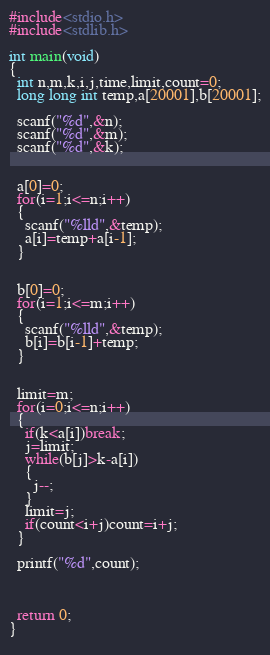<code> <loc_0><loc_0><loc_500><loc_500><_C_>#include<stdio.h>
#include<stdlib.h>

int main(void)
{
  int n,m,k,i,j,time,limit,count=0;
  long long int temp,a[20001],b[20001];
  
  scanf("%d",&n);
  scanf("%d",&m);
  scanf("%d",&k);
  
  
  a[0]=0;
  for(i=1;i<=n;i++)
  {
    scanf("%lld",&temp);
    a[i]=temp+a[i-1];
  }
  

  b[0]=0;
  for(i=1;i<=m;i++)
  {
    scanf("%lld",&temp);
    b[i]=b[i-1]+temp;
  }
  

  limit=m;
  for(i=0;i<=n;i++)
  {
    if(k<a[i])break;
    j=limit;
    while(b[j]>k-a[i])
    {
      j--;
    }
    limit=j;
    if(count<i+j)count=i+j;
  }
  
  printf("%d",count);
  
  
  
  return 0;
}
  </code> 